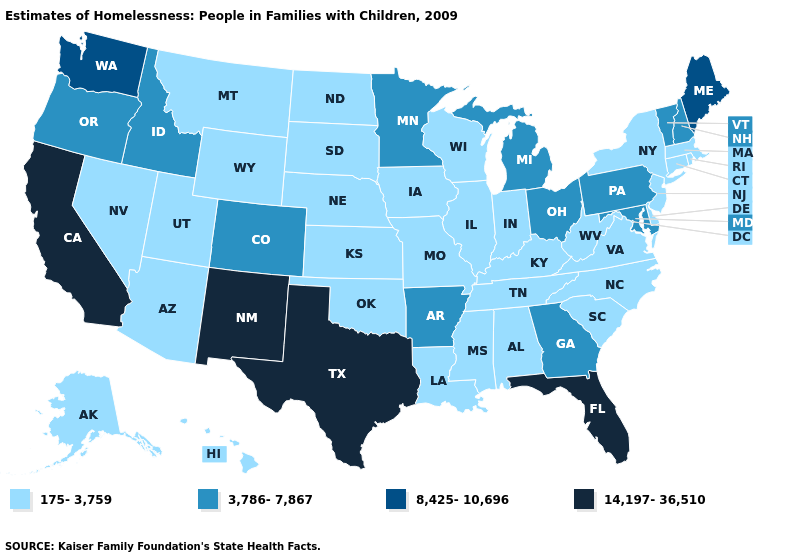Does the map have missing data?
Short answer required. No. What is the highest value in the MidWest ?
Concise answer only. 3,786-7,867. Does Alaska have the highest value in the USA?
Short answer required. No. What is the value of Ohio?
Write a very short answer. 3,786-7,867. What is the highest value in states that border Florida?
Write a very short answer. 3,786-7,867. Among the states that border Oklahoma , does Kansas have the lowest value?
Write a very short answer. Yes. What is the highest value in the MidWest ?
Be succinct. 3,786-7,867. Does Georgia have a lower value than Missouri?
Give a very brief answer. No. Which states hav the highest value in the MidWest?
Answer briefly. Michigan, Minnesota, Ohio. Name the states that have a value in the range 175-3,759?
Keep it brief. Alabama, Alaska, Arizona, Connecticut, Delaware, Hawaii, Illinois, Indiana, Iowa, Kansas, Kentucky, Louisiana, Massachusetts, Mississippi, Missouri, Montana, Nebraska, Nevada, New Jersey, New York, North Carolina, North Dakota, Oklahoma, Rhode Island, South Carolina, South Dakota, Tennessee, Utah, Virginia, West Virginia, Wisconsin, Wyoming. Does Alaska have the lowest value in the West?
Concise answer only. Yes. What is the value of Arizona?
Short answer required. 175-3,759. How many symbols are there in the legend?
Answer briefly. 4. What is the lowest value in states that border Indiana?
Write a very short answer. 175-3,759. Does the map have missing data?
Write a very short answer. No. 